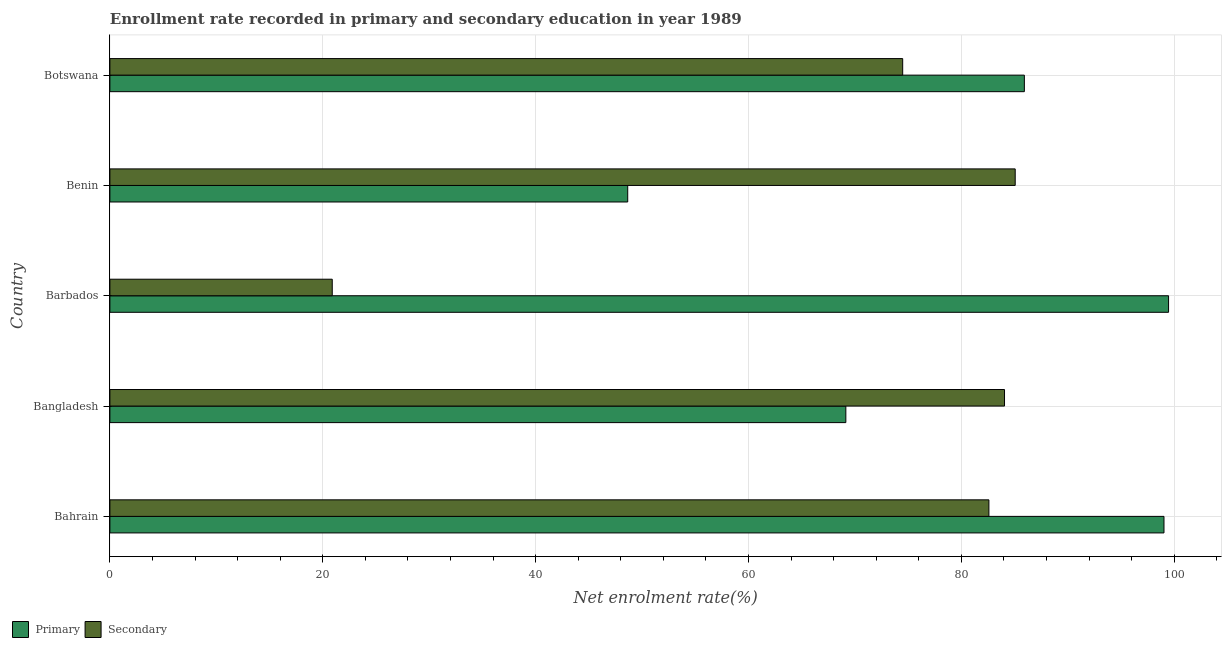How many different coloured bars are there?
Offer a terse response. 2. How many groups of bars are there?
Provide a short and direct response. 5. Are the number of bars per tick equal to the number of legend labels?
Your answer should be compact. Yes. What is the label of the 2nd group of bars from the top?
Make the answer very short. Benin. What is the enrollment rate in primary education in Botswana?
Ensure brevity in your answer.  85.92. Across all countries, what is the maximum enrollment rate in primary education?
Your response must be concise. 99.47. Across all countries, what is the minimum enrollment rate in primary education?
Keep it short and to the point. 48.65. In which country was the enrollment rate in primary education maximum?
Your response must be concise. Barbados. In which country was the enrollment rate in primary education minimum?
Your answer should be compact. Benin. What is the total enrollment rate in primary education in the graph?
Keep it short and to the point. 402.24. What is the difference between the enrollment rate in primary education in Barbados and that in Botswana?
Ensure brevity in your answer.  13.55. What is the difference between the enrollment rate in primary education in Botswana and the enrollment rate in secondary education in Bangladesh?
Offer a very short reply. 1.86. What is the average enrollment rate in primary education per country?
Provide a short and direct response. 80.45. What is the difference between the enrollment rate in secondary education and enrollment rate in primary education in Barbados?
Give a very brief answer. -78.58. What is the ratio of the enrollment rate in secondary education in Bangladesh to that in Benin?
Keep it short and to the point. 0.99. What is the difference between the highest and the second highest enrollment rate in primary education?
Your response must be concise. 0.43. What is the difference between the highest and the lowest enrollment rate in secondary education?
Keep it short and to the point. 64.17. In how many countries, is the enrollment rate in primary education greater than the average enrollment rate in primary education taken over all countries?
Keep it short and to the point. 3. Is the sum of the enrollment rate in primary education in Bahrain and Botswana greater than the maximum enrollment rate in secondary education across all countries?
Give a very brief answer. Yes. What does the 2nd bar from the top in Botswana represents?
Provide a short and direct response. Primary. What does the 1st bar from the bottom in Barbados represents?
Give a very brief answer. Primary. How many bars are there?
Your answer should be compact. 10. What is the difference between two consecutive major ticks on the X-axis?
Your response must be concise. 20. Does the graph contain any zero values?
Make the answer very short. No. Where does the legend appear in the graph?
Provide a succinct answer. Bottom left. How are the legend labels stacked?
Offer a terse response. Horizontal. What is the title of the graph?
Provide a succinct answer. Enrollment rate recorded in primary and secondary education in year 1989. Does "Primary" appear as one of the legend labels in the graph?
Provide a succinct answer. Yes. What is the label or title of the X-axis?
Your answer should be compact. Net enrolment rate(%). What is the label or title of the Y-axis?
Your response must be concise. Country. What is the Net enrolment rate(%) in Primary in Bahrain?
Provide a succinct answer. 99.04. What is the Net enrolment rate(%) of Secondary in Bahrain?
Provide a succinct answer. 82.59. What is the Net enrolment rate(%) in Primary in Bangladesh?
Offer a very short reply. 69.15. What is the Net enrolment rate(%) in Secondary in Bangladesh?
Ensure brevity in your answer.  84.06. What is the Net enrolment rate(%) of Primary in Barbados?
Provide a short and direct response. 99.47. What is the Net enrolment rate(%) of Secondary in Barbados?
Provide a succinct answer. 20.89. What is the Net enrolment rate(%) of Primary in Benin?
Your response must be concise. 48.65. What is the Net enrolment rate(%) of Secondary in Benin?
Provide a succinct answer. 85.06. What is the Net enrolment rate(%) in Primary in Botswana?
Your answer should be very brief. 85.92. What is the Net enrolment rate(%) in Secondary in Botswana?
Your answer should be compact. 74.49. Across all countries, what is the maximum Net enrolment rate(%) in Primary?
Provide a succinct answer. 99.47. Across all countries, what is the maximum Net enrolment rate(%) in Secondary?
Offer a terse response. 85.06. Across all countries, what is the minimum Net enrolment rate(%) of Primary?
Ensure brevity in your answer.  48.65. Across all countries, what is the minimum Net enrolment rate(%) in Secondary?
Ensure brevity in your answer.  20.89. What is the total Net enrolment rate(%) in Primary in the graph?
Give a very brief answer. 402.24. What is the total Net enrolment rate(%) in Secondary in the graph?
Offer a very short reply. 347.1. What is the difference between the Net enrolment rate(%) in Primary in Bahrain and that in Bangladesh?
Give a very brief answer. 29.89. What is the difference between the Net enrolment rate(%) in Secondary in Bahrain and that in Bangladesh?
Provide a succinct answer. -1.47. What is the difference between the Net enrolment rate(%) in Primary in Bahrain and that in Barbados?
Offer a terse response. -0.43. What is the difference between the Net enrolment rate(%) in Secondary in Bahrain and that in Barbados?
Your answer should be very brief. 61.7. What is the difference between the Net enrolment rate(%) in Primary in Bahrain and that in Benin?
Your answer should be very brief. 50.39. What is the difference between the Net enrolment rate(%) in Secondary in Bahrain and that in Benin?
Offer a very short reply. -2.47. What is the difference between the Net enrolment rate(%) in Primary in Bahrain and that in Botswana?
Make the answer very short. 13.12. What is the difference between the Net enrolment rate(%) of Secondary in Bahrain and that in Botswana?
Give a very brief answer. 8.1. What is the difference between the Net enrolment rate(%) of Primary in Bangladesh and that in Barbados?
Provide a succinct answer. -30.32. What is the difference between the Net enrolment rate(%) in Secondary in Bangladesh and that in Barbados?
Keep it short and to the point. 63.17. What is the difference between the Net enrolment rate(%) of Primary in Bangladesh and that in Benin?
Provide a short and direct response. 20.5. What is the difference between the Net enrolment rate(%) of Secondary in Bangladesh and that in Benin?
Give a very brief answer. -1. What is the difference between the Net enrolment rate(%) in Primary in Bangladesh and that in Botswana?
Ensure brevity in your answer.  -16.77. What is the difference between the Net enrolment rate(%) of Secondary in Bangladesh and that in Botswana?
Your answer should be very brief. 9.57. What is the difference between the Net enrolment rate(%) in Primary in Barbados and that in Benin?
Offer a very short reply. 50.82. What is the difference between the Net enrolment rate(%) in Secondary in Barbados and that in Benin?
Make the answer very short. -64.17. What is the difference between the Net enrolment rate(%) of Primary in Barbados and that in Botswana?
Ensure brevity in your answer.  13.55. What is the difference between the Net enrolment rate(%) in Secondary in Barbados and that in Botswana?
Provide a succinct answer. -53.6. What is the difference between the Net enrolment rate(%) of Primary in Benin and that in Botswana?
Make the answer very short. -37.27. What is the difference between the Net enrolment rate(%) in Secondary in Benin and that in Botswana?
Your answer should be compact. 10.57. What is the difference between the Net enrolment rate(%) in Primary in Bahrain and the Net enrolment rate(%) in Secondary in Bangladesh?
Offer a very short reply. 14.98. What is the difference between the Net enrolment rate(%) of Primary in Bahrain and the Net enrolment rate(%) of Secondary in Barbados?
Keep it short and to the point. 78.15. What is the difference between the Net enrolment rate(%) in Primary in Bahrain and the Net enrolment rate(%) in Secondary in Benin?
Offer a very short reply. 13.98. What is the difference between the Net enrolment rate(%) in Primary in Bahrain and the Net enrolment rate(%) in Secondary in Botswana?
Your answer should be compact. 24.55. What is the difference between the Net enrolment rate(%) in Primary in Bangladesh and the Net enrolment rate(%) in Secondary in Barbados?
Keep it short and to the point. 48.26. What is the difference between the Net enrolment rate(%) of Primary in Bangladesh and the Net enrolment rate(%) of Secondary in Benin?
Ensure brevity in your answer.  -15.91. What is the difference between the Net enrolment rate(%) in Primary in Bangladesh and the Net enrolment rate(%) in Secondary in Botswana?
Give a very brief answer. -5.34. What is the difference between the Net enrolment rate(%) of Primary in Barbados and the Net enrolment rate(%) of Secondary in Benin?
Make the answer very short. 14.41. What is the difference between the Net enrolment rate(%) of Primary in Barbados and the Net enrolment rate(%) of Secondary in Botswana?
Make the answer very short. 24.98. What is the difference between the Net enrolment rate(%) of Primary in Benin and the Net enrolment rate(%) of Secondary in Botswana?
Provide a succinct answer. -25.84. What is the average Net enrolment rate(%) of Primary per country?
Your answer should be very brief. 80.45. What is the average Net enrolment rate(%) in Secondary per country?
Offer a very short reply. 69.42. What is the difference between the Net enrolment rate(%) in Primary and Net enrolment rate(%) in Secondary in Bahrain?
Your response must be concise. 16.45. What is the difference between the Net enrolment rate(%) in Primary and Net enrolment rate(%) in Secondary in Bangladesh?
Keep it short and to the point. -14.91. What is the difference between the Net enrolment rate(%) of Primary and Net enrolment rate(%) of Secondary in Barbados?
Offer a terse response. 78.58. What is the difference between the Net enrolment rate(%) of Primary and Net enrolment rate(%) of Secondary in Benin?
Offer a very short reply. -36.41. What is the difference between the Net enrolment rate(%) in Primary and Net enrolment rate(%) in Secondary in Botswana?
Provide a succinct answer. 11.43. What is the ratio of the Net enrolment rate(%) of Primary in Bahrain to that in Bangladesh?
Provide a succinct answer. 1.43. What is the ratio of the Net enrolment rate(%) of Secondary in Bahrain to that in Bangladesh?
Offer a very short reply. 0.98. What is the ratio of the Net enrolment rate(%) of Primary in Bahrain to that in Barbados?
Give a very brief answer. 1. What is the ratio of the Net enrolment rate(%) of Secondary in Bahrain to that in Barbados?
Offer a terse response. 3.95. What is the ratio of the Net enrolment rate(%) of Primary in Bahrain to that in Benin?
Give a very brief answer. 2.04. What is the ratio of the Net enrolment rate(%) in Secondary in Bahrain to that in Benin?
Give a very brief answer. 0.97. What is the ratio of the Net enrolment rate(%) in Primary in Bahrain to that in Botswana?
Provide a succinct answer. 1.15. What is the ratio of the Net enrolment rate(%) of Secondary in Bahrain to that in Botswana?
Make the answer very short. 1.11. What is the ratio of the Net enrolment rate(%) of Primary in Bangladesh to that in Barbados?
Your answer should be very brief. 0.7. What is the ratio of the Net enrolment rate(%) of Secondary in Bangladesh to that in Barbados?
Make the answer very short. 4.02. What is the ratio of the Net enrolment rate(%) of Primary in Bangladesh to that in Benin?
Provide a short and direct response. 1.42. What is the ratio of the Net enrolment rate(%) in Secondary in Bangladesh to that in Benin?
Make the answer very short. 0.99. What is the ratio of the Net enrolment rate(%) of Primary in Bangladesh to that in Botswana?
Your response must be concise. 0.8. What is the ratio of the Net enrolment rate(%) in Secondary in Bangladesh to that in Botswana?
Keep it short and to the point. 1.13. What is the ratio of the Net enrolment rate(%) in Primary in Barbados to that in Benin?
Your answer should be compact. 2.04. What is the ratio of the Net enrolment rate(%) of Secondary in Barbados to that in Benin?
Offer a very short reply. 0.25. What is the ratio of the Net enrolment rate(%) of Primary in Barbados to that in Botswana?
Ensure brevity in your answer.  1.16. What is the ratio of the Net enrolment rate(%) in Secondary in Barbados to that in Botswana?
Provide a short and direct response. 0.28. What is the ratio of the Net enrolment rate(%) in Primary in Benin to that in Botswana?
Offer a very short reply. 0.57. What is the ratio of the Net enrolment rate(%) in Secondary in Benin to that in Botswana?
Give a very brief answer. 1.14. What is the difference between the highest and the second highest Net enrolment rate(%) of Primary?
Offer a very short reply. 0.43. What is the difference between the highest and the lowest Net enrolment rate(%) in Primary?
Give a very brief answer. 50.82. What is the difference between the highest and the lowest Net enrolment rate(%) in Secondary?
Provide a succinct answer. 64.17. 